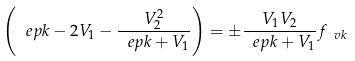Convert formula to latex. <formula><loc_0><loc_0><loc_500><loc_500>\left ( \ e p k - 2 V _ { 1 } - \frac { V _ { 2 } ^ { 2 } } { \ e p k + V _ { 1 } } \right ) = \pm \frac { V _ { 1 } V _ { 2 } } { \ e p k + V _ { 1 } } f _ { \ v k }</formula> 